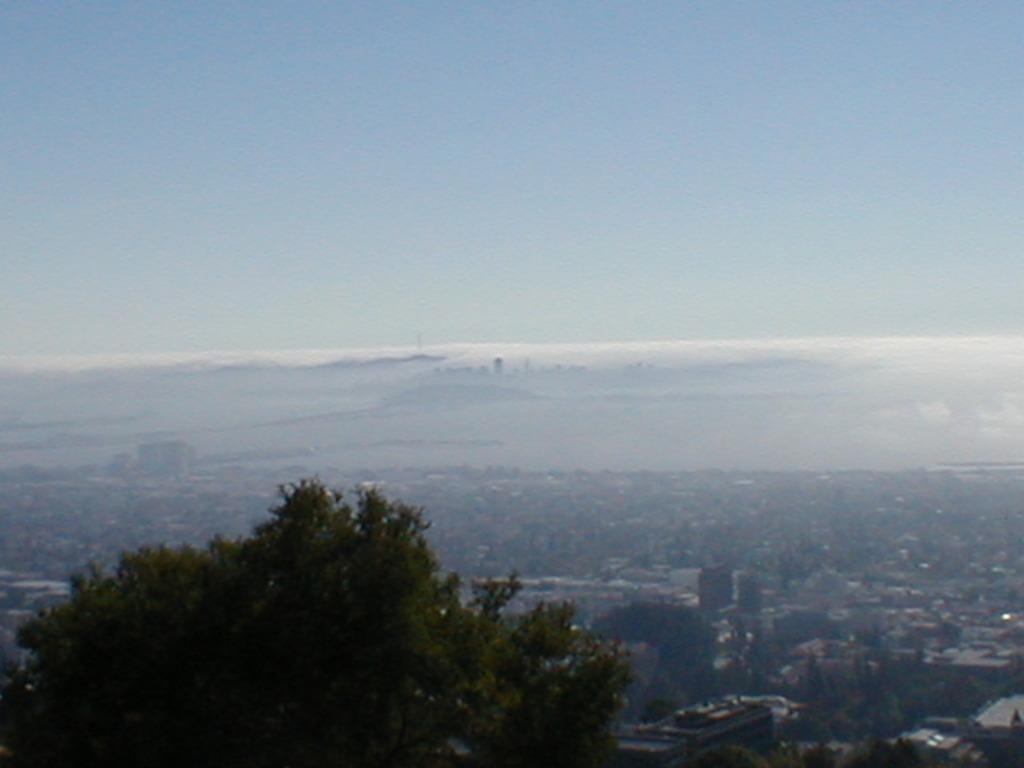What type of vegetation can be seen in the image? There are trees in the image. What is the color of the trees? The trees are green in color. What can be seen in the background of the image? There are buildings in the background of the image. What is visible in the sky in the image? The sky is visible in the image, and it is blue and white in color. What trail is visible in the image? There is no trail visible in the image; it features trees, buildings, and a blue and white sky. 